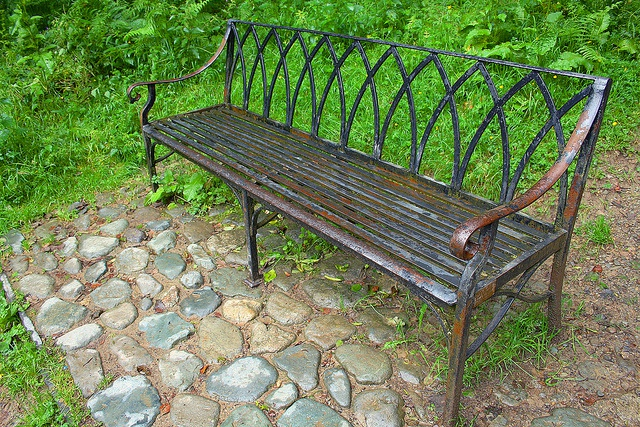Describe the objects in this image and their specific colors. I can see a bench in darkgreen, gray, black, and green tones in this image. 